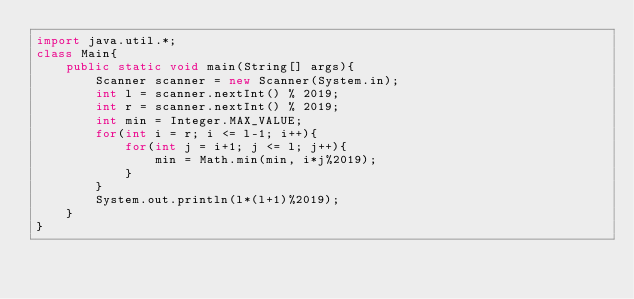<code> <loc_0><loc_0><loc_500><loc_500><_Java_>import java.util.*;
class Main{
    public static void main(String[] args){
        Scanner scanner = new Scanner(System.in);
        int l = scanner.nextInt() % 2019;
        int r = scanner.nextInt() % 2019;
        int min = Integer.MAX_VALUE;
        for(int i = r; i <= l-1; i++){
            for(int j = i+1; j <= l; j++){
                min = Math.min(min, i*j%2019);
            }
        }
        System.out.println(l*(l+1)%2019);
    }
}

</code> 